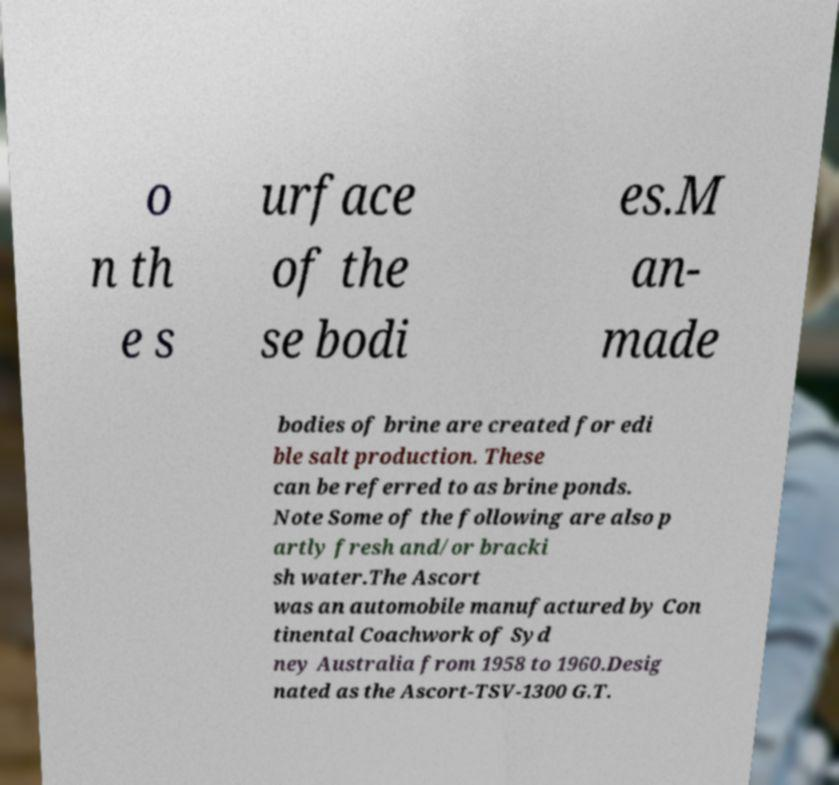Please read and relay the text visible in this image. What does it say? o n th e s urface of the se bodi es.M an- made bodies of brine are created for edi ble salt production. These can be referred to as brine ponds. Note Some of the following are also p artly fresh and/or bracki sh water.The Ascort was an automobile manufactured by Con tinental Coachwork of Syd ney Australia from 1958 to 1960.Desig nated as the Ascort-TSV-1300 G.T. 